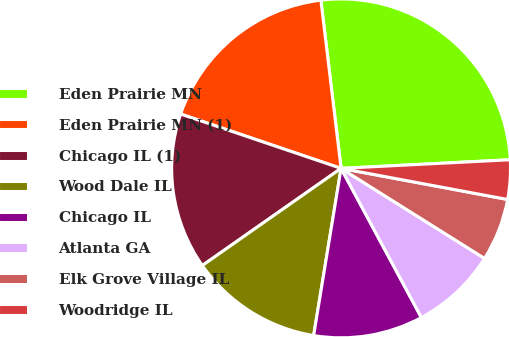Convert chart. <chart><loc_0><loc_0><loc_500><loc_500><pie_chart><fcel>Eden Prairie MN<fcel>Eden Prairie MN (1)<fcel>Chicago IL (1)<fcel>Wood Dale IL<fcel>Chicago IL<fcel>Atlanta GA<fcel>Elk Grove Village IL<fcel>Woodridge IL<nl><fcel>26.09%<fcel>17.9%<fcel>14.92%<fcel>12.69%<fcel>10.45%<fcel>8.22%<fcel>5.98%<fcel>3.75%<nl></chart> 